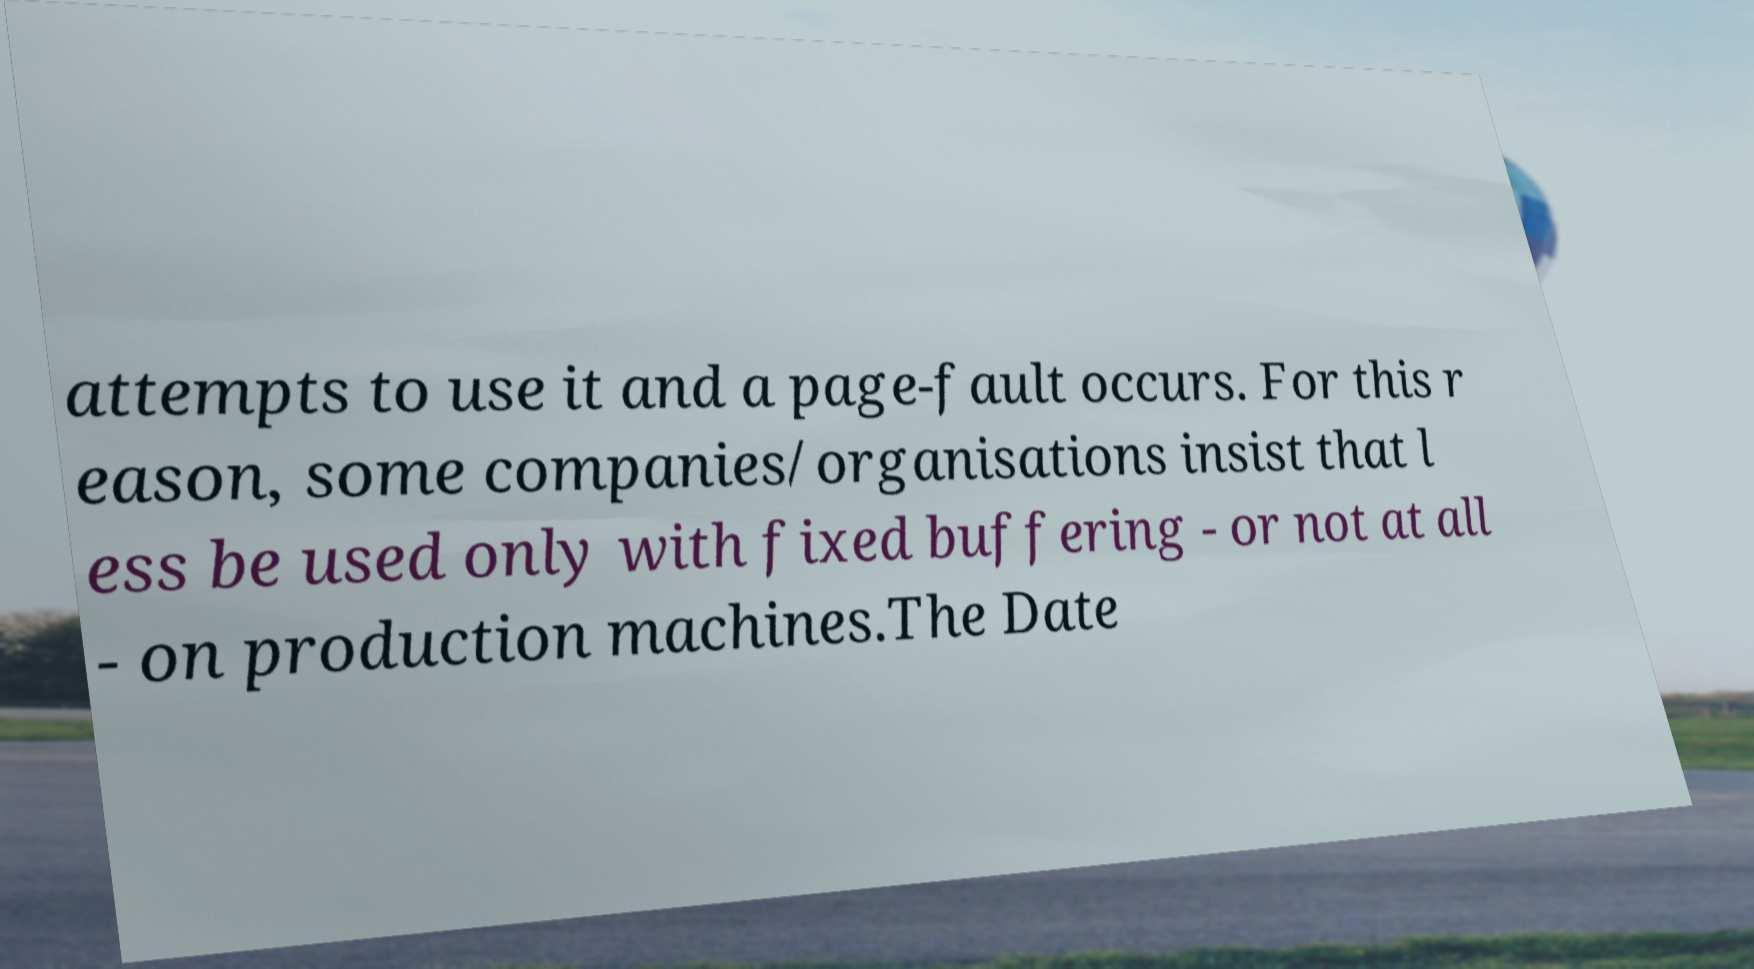What messages or text are displayed in this image? I need them in a readable, typed format. attempts to use it and a page-fault occurs. For this r eason, some companies/organisations insist that l ess be used only with fixed buffering - or not at all - on production machines.The Date 